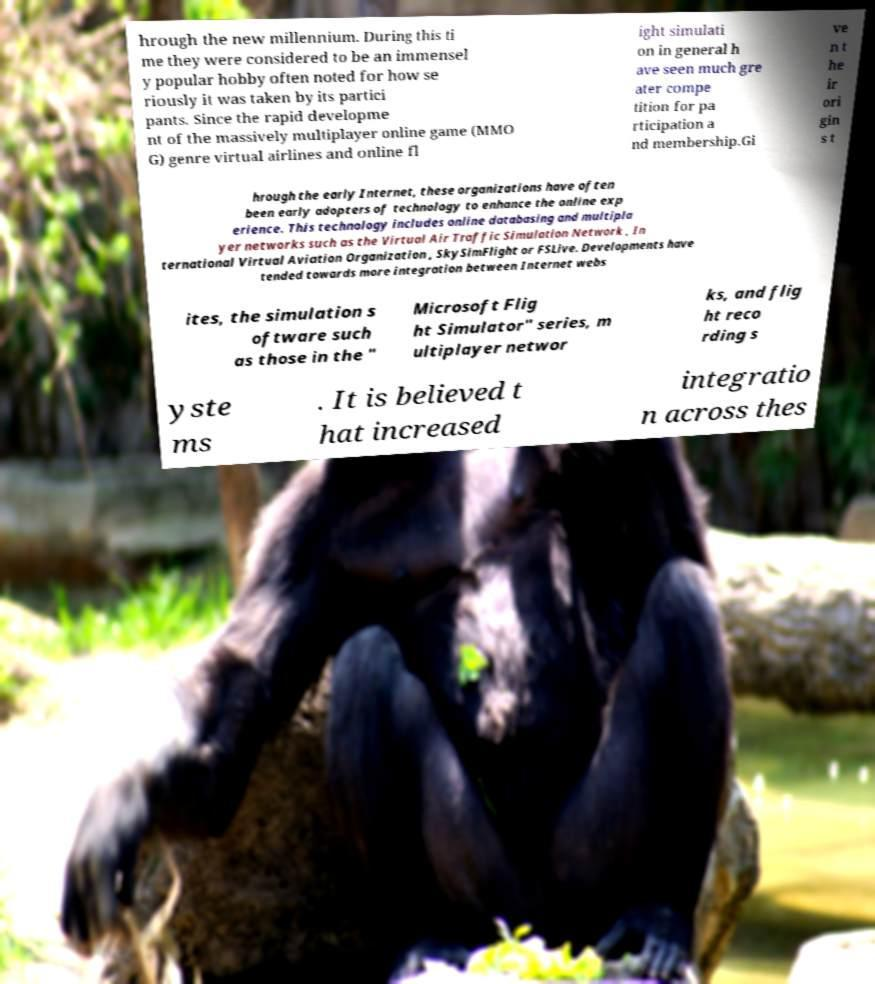Please identify and transcribe the text found in this image. hrough the new millennium. During this ti me they were considered to be an immensel y popular hobby often noted for how se riously it was taken by its partici pants. Since the rapid developme nt of the massively multiplayer online game (MMO G) genre virtual airlines and online fl ight simulati on in general h ave seen much gre ater compe tition for pa rticipation a nd membership.Gi ve n t he ir ori gin s t hrough the early Internet, these organizations have often been early adopters of technology to enhance the online exp erience. This technology includes online databasing and multipla yer networks such as the Virtual Air Traffic Simulation Network , In ternational Virtual Aviation Organization , SkySimFlight or FSLive. Developments have tended towards more integration between Internet webs ites, the simulation s oftware such as those in the " Microsoft Flig ht Simulator" series, m ultiplayer networ ks, and flig ht reco rding s yste ms . It is believed t hat increased integratio n across thes 